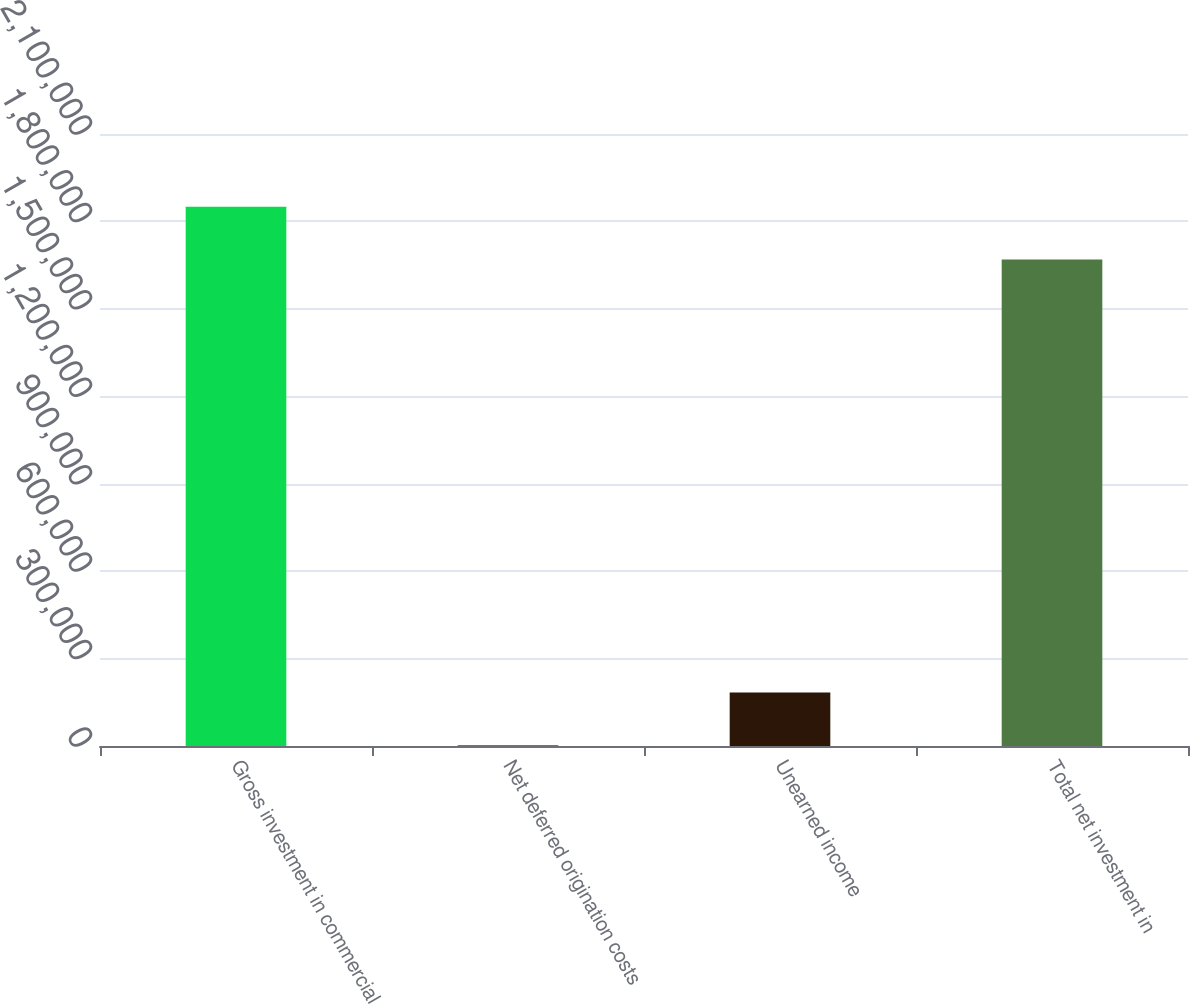<chart> <loc_0><loc_0><loc_500><loc_500><bar_chart><fcel>Gross investment in commercial<fcel>Net deferred origination costs<fcel>Unearned income<fcel>Total net investment in<nl><fcel>1.85025e+06<fcel>2805<fcel>183491<fcel>1.66957e+06<nl></chart> 